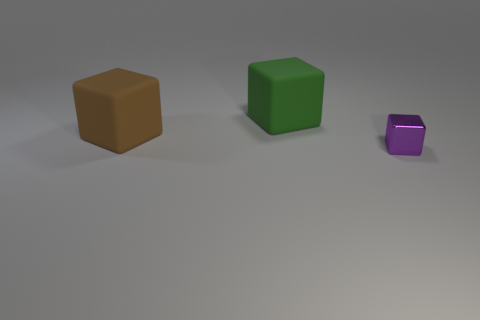Add 3 green cubes. How many objects exist? 6 Add 3 rubber things. How many rubber things exist? 5 Subtract 0 red balls. How many objects are left? 3 Subtract all green rubber blocks. Subtract all brown objects. How many objects are left? 1 Add 3 big brown matte cubes. How many big brown matte cubes are left? 4 